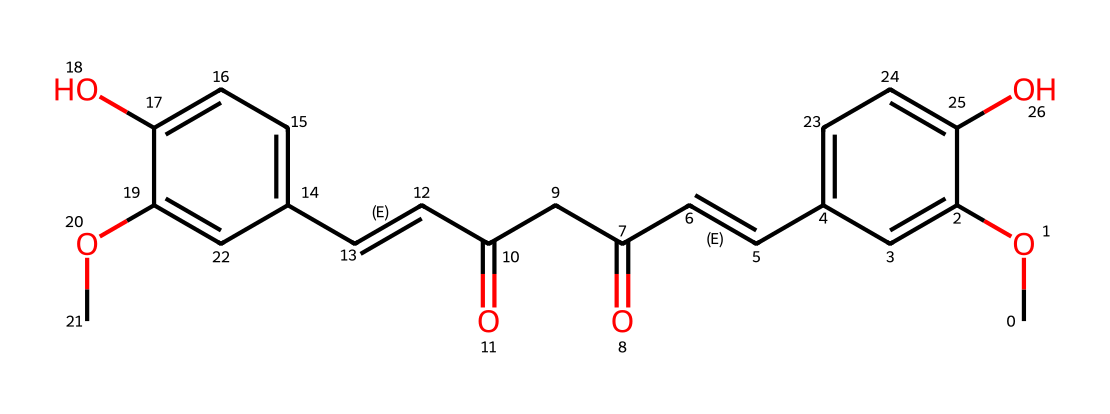What is the molecular formula of curcumin? By analyzing the structure represented by the SMILES, we can deduce the molecular formula. In this structure, there are a total of 21 carbon atoms, 20 hydrogen atoms, and 6 oxygen atoms. Therefore, the molecular formula of curcumin is C21H20O6.
Answer: C21H20O6 How many rings are present in the structure of curcumin? The visual representation of curcumin shows two distinct aromatic rings within the molecule's structure, based on the cyclic arrangements of carbon atoms.
Answer: 2 What type of functional groups can be identified in curcumin? Looking at the structure, we can identify functional groups like methoxy (-OCH3), hydroxyl (-OH), and carbonyl (C=O) groups based on their specific attachments to the molecular framework.
Answer: methoxy, hydroxyl, carbonyl How many double bonds are present in the structure of curcumin? In the molecule, there are two segments with double bonds connecting carbon atoms indicated by the C=C representation within the SMILES. These are typical for unsaturated compounds.
Answer: 2 What kind of antioxidant properties is curcumin known for? Curcumin is recognized for its ability to scavenge free radicals and reduce oxidative stress in biological systems, which is attributed to its aromatic and phenolic structures that stabilize free radicals.
Answer: radical scavenging What roles do the hydroxyl groups play in curcumin's activity? The hydroxyl groups enhance the molecule's ability to act as an antioxidant by donating protons to free radicals, thus neutralizing them and reducing oxidative damage.
Answer: proton donation What are the implications of curcumin's aromatic structure for its biological activity? The presence of aromatic rings contributes to the molecule's stability and ability to interact with other biological compounds, influencing its antioxidant activity and potential medicinal benefits.
Answer: stability and interactions 